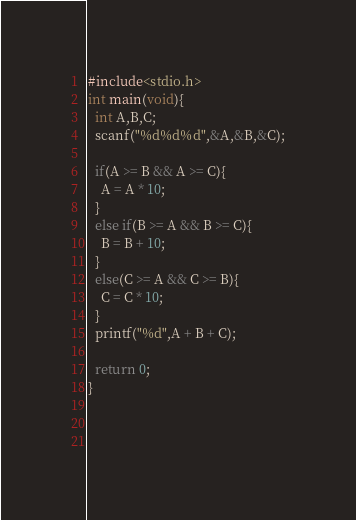<code> <loc_0><loc_0><loc_500><loc_500><_C_>#include<stdio.h>
int main(void){
  int A,B,C;
  scanf("%d%d%d",&A,&B,&C);
  
  if(A >= B && A >= C){
    A = A * 10;
  }
  else if(B >= A && B >= C){
    B = B + 10;
  }
  else(C >= A && C >= B){
    C = C * 10;
  }
  printf("%d",A + B + C);
  
  return 0;
}

  
    </code> 